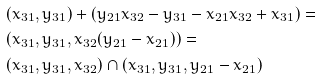<formula> <loc_0><loc_0><loc_500><loc_500>& ( x _ { 3 1 } , y _ { 3 1 } ) + ( y _ { 2 1 } x _ { 3 2 } - y _ { 3 1 } - x _ { 2 1 } x _ { 3 2 } + x _ { 3 1 } ) = \\ & ( x _ { 3 1 } , y _ { 3 1 } , x _ { 3 2 } ( y _ { 2 1 } - x _ { 2 1 } ) ) = \\ & ( x _ { 3 1 } , y _ { 3 1 } , x _ { 3 2 } ) \cap ( x _ { 3 1 } , y _ { 3 1 } , y _ { 2 1 } - x _ { 2 1 } )</formula> 